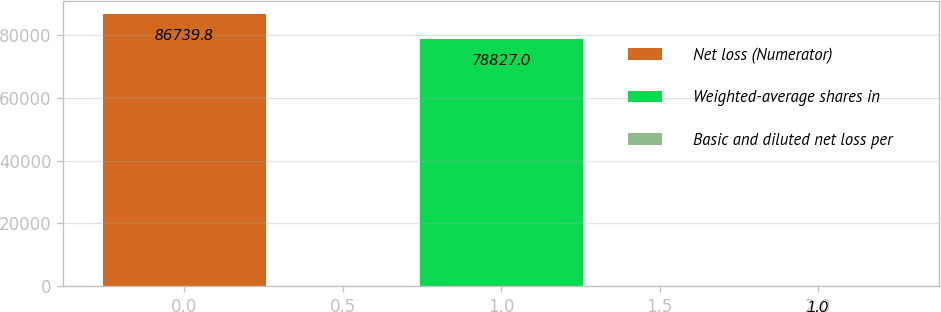<chart> <loc_0><loc_0><loc_500><loc_500><bar_chart><fcel>Net loss (Numerator)<fcel>Weighted-average shares in<fcel>Basic and diluted net loss per<nl><fcel>86739.8<fcel>78827<fcel>1<nl></chart> 